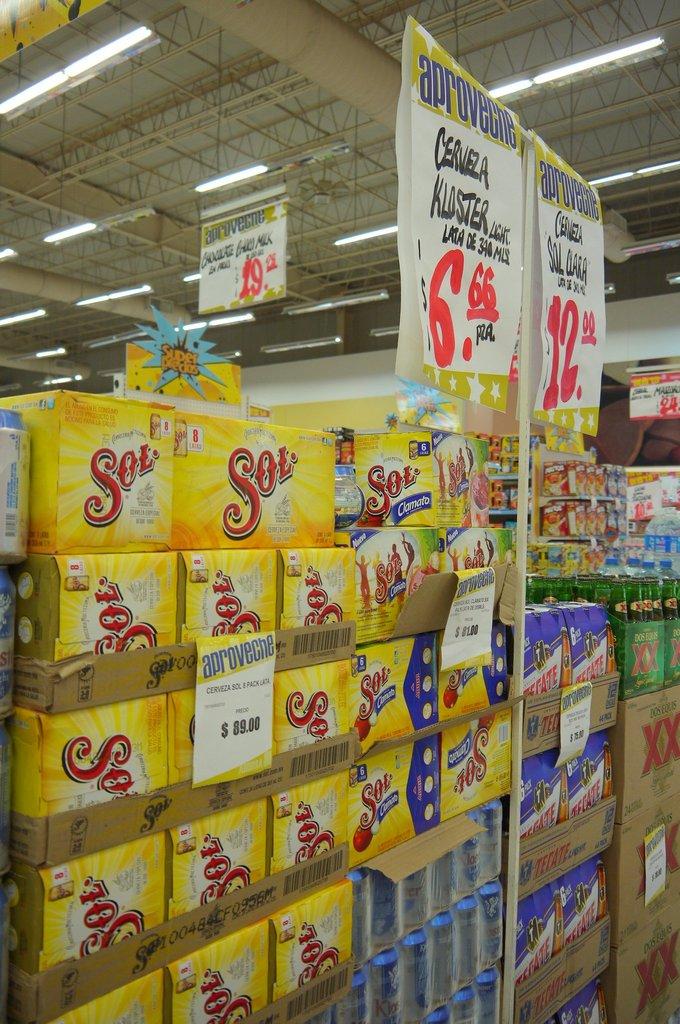What brand of beer is priced at $6.66?
Your response must be concise. Kloster. There are yellow cokoes?
Make the answer very short. No. 